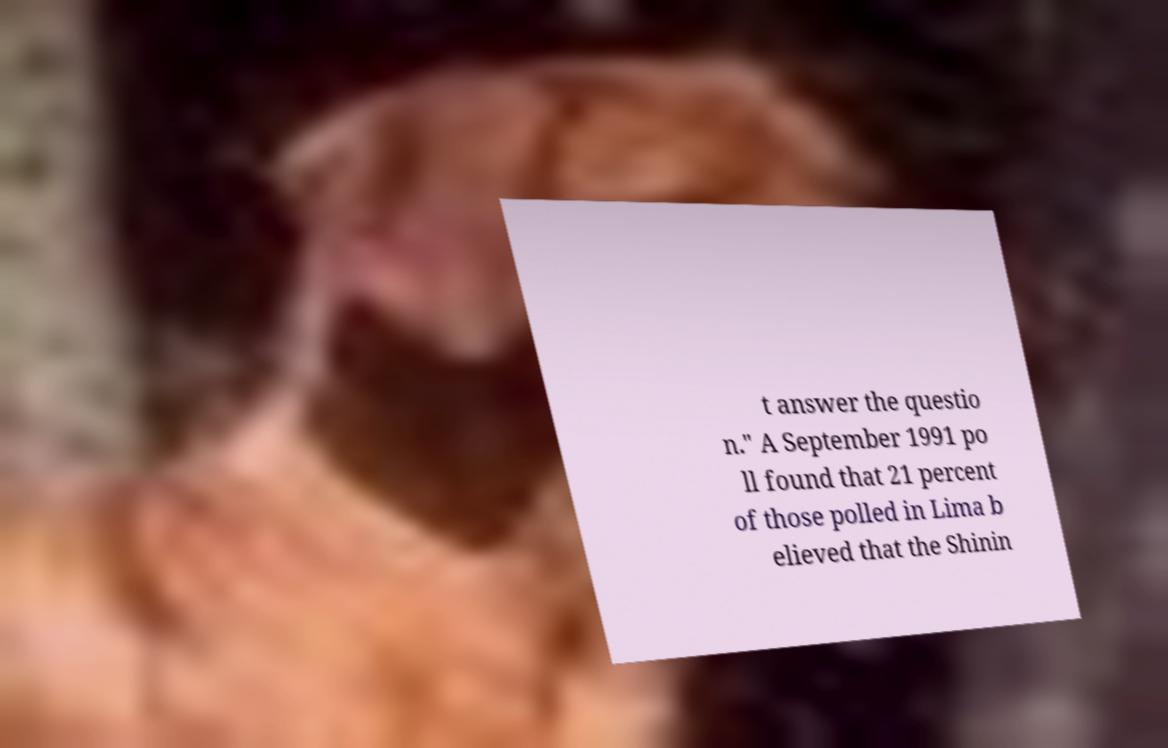For documentation purposes, I need the text within this image transcribed. Could you provide that? t answer the questio n." A September 1991 po ll found that 21 percent of those polled in Lima b elieved that the Shinin 